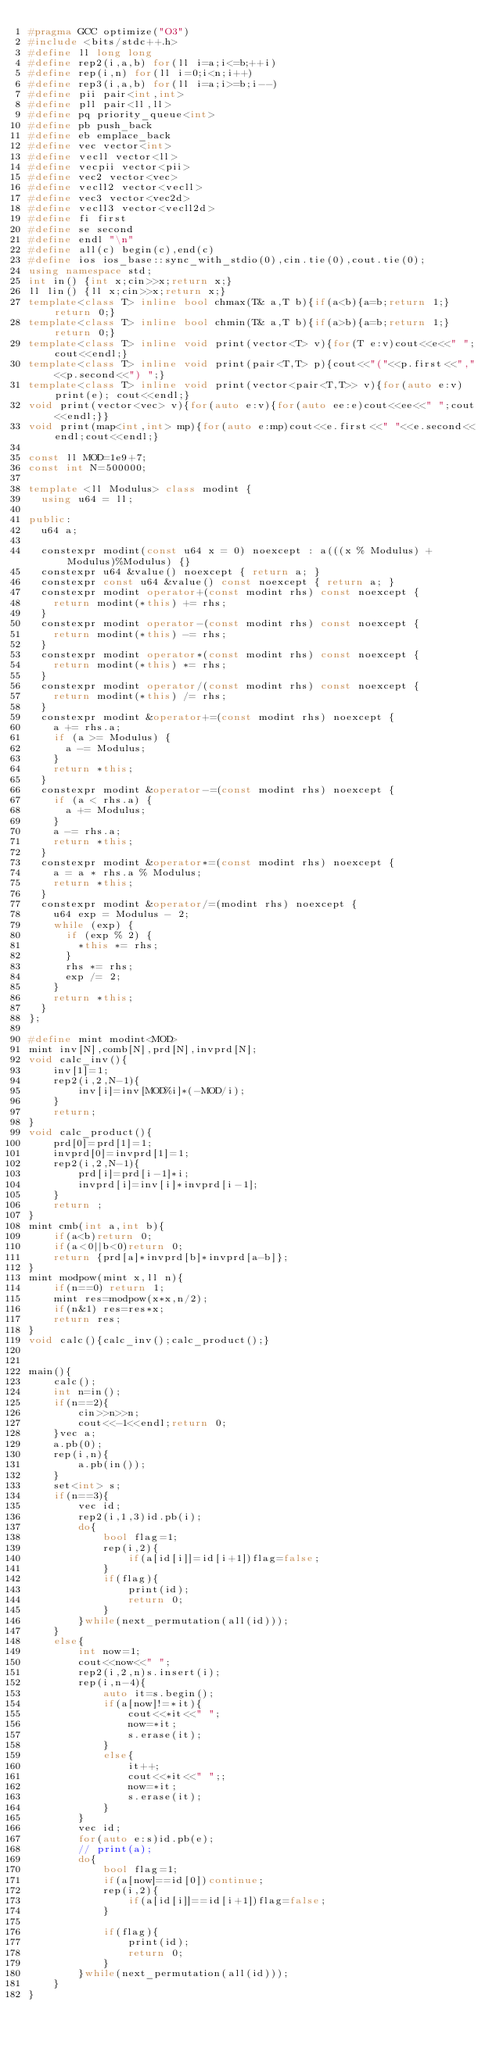Convert code to text. <code><loc_0><loc_0><loc_500><loc_500><_C++_>#pragma GCC optimize("O3")
#include <bits/stdc++.h>
#define ll long long
#define rep2(i,a,b) for(ll i=a;i<=b;++i)
#define rep(i,n) for(ll i=0;i<n;i++)
#define rep3(i,a,b) for(ll i=a;i>=b;i--)
#define pii pair<int,int>
#define pll pair<ll,ll>
#define pq priority_queue<int>
#define pb push_back
#define eb emplace_back
#define vec vector<int>
#define vecll vector<ll>
#define vecpii vector<pii>
#define vec2 vector<vec>
#define vecll2 vector<vecll>
#define vec3 vector<vec2d>
#define vecll3 vector<vecll2d>
#define fi first
#define se second
#define endl "\n"
#define all(c) begin(c),end(c)
#define ios ios_base::sync_with_stdio(0),cin.tie(0),cout.tie(0);
using namespace std;
int in() {int x;cin>>x;return x;}
ll lin() {ll x;cin>>x;return x;}
template<class T> inline bool chmax(T& a,T b){if(a<b){a=b;return 1;}return 0;}
template<class T> inline bool chmin(T& a,T b){if(a>b){a=b;return 1;}return 0;}
template<class T> inline void print(vector<T> v){for(T e:v)cout<<e<<" ";cout<<endl;}
template<class T> inline void print(pair<T,T> p){cout<<"("<<p.first<<","<<p.second<<") ";}
template<class T> inline void print(vector<pair<T,T>> v){for(auto e:v)print(e); cout<<endl;}
void print(vector<vec> v){for(auto e:v){for(auto ee:e)cout<<ee<<" ";cout<<endl;}}
void print(map<int,int> mp){for(auto e:mp)cout<<e.first<<" "<<e.second<<endl;cout<<endl;}

const ll MOD=1e9+7;
const int N=500000;
 
template <ll Modulus> class modint {
  using u64 = ll;
 
public:
  u64 a;
 
  constexpr modint(const u64 x = 0) noexcept : a(((x % Modulus) + Modulus)%Modulus) {}
  constexpr u64 &value() noexcept { return a; }
  constexpr const u64 &value() const noexcept { return a; }
  constexpr modint operator+(const modint rhs) const noexcept {
    return modint(*this) += rhs;
  }
  constexpr modint operator-(const modint rhs) const noexcept {
    return modint(*this) -= rhs;
  }
  constexpr modint operator*(const modint rhs) const noexcept {
    return modint(*this) *= rhs;
  }
  constexpr modint operator/(const modint rhs) const noexcept {
    return modint(*this) /= rhs;
  }
  constexpr modint &operator+=(const modint rhs) noexcept {
    a += rhs.a;
    if (a >= Modulus) {
      a -= Modulus;
    }
    return *this;
  }
  constexpr modint &operator-=(const modint rhs) noexcept {
    if (a < rhs.a) {
      a += Modulus;
    }
    a -= rhs.a;
    return *this;
  }
  constexpr modint &operator*=(const modint rhs) noexcept {
    a = a * rhs.a % Modulus;
    return *this;
  }
  constexpr modint &operator/=(modint rhs) noexcept {
    u64 exp = Modulus - 2;
    while (exp) {
      if (exp % 2) {
        *this *= rhs;
      }
      rhs *= rhs;
      exp /= 2;
    }
    return *this;
  }
};
 
#define mint modint<MOD>
mint inv[N],comb[N],prd[N],invprd[N];
void calc_inv(){
    inv[1]=1;
    rep2(i,2,N-1){
        inv[i]=inv[MOD%i]*(-MOD/i);
    }
    return;
}
void calc_product(){
    prd[0]=prd[1]=1;
    invprd[0]=invprd[1]=1;
    rep2(i,2,N-1){
        prd[i]=prd[i-1]*i;
        invprd[i]=inv[i]*invprd[i-1];
    }
    return ;
}
mint cmb(int a,int b){
    if(a<b)return 0;
    if(a<0||b<0)return 0;
    return {prd[a]*invprd[b]*invprd[a-b]};
}
mint modpow(mint x,ll n){
    if(n==0) return 1;
    mint res=modpow(x*x,n/2);
    if(n&1) res=res*x;
    return res;
}
void calc(){calc_inv();calc_product();}
 

main(){
    calc();
    int n=in();
    if(n==2){
        cin>>n>>n;
        cout<<-1<<endl;return 0;
    }vec a;
    a.pb(0);
    rep(i,n){
        a.pb(in());
    }
    set<int> s;
    if(n==3){
        vec id;
        rep2(i,1,3)id.pb(i);
        do{
            bool flag=1;
            rep(i,2){
                if(a[id[i]]=id[i+1])flag=false;
            }
            if(flag){
                print(id);
                return 0;
            }
        }while(next_permutation(all(id)));
    }
    else{
        int now=1;
        cout<<now<<" ";
        rep2(i,2,n)s.insert(i);
        rep(i,n-4){
            auto it=s.begin();
            if(a[now]!=*it){
                cout<<*it<<" ";
                now=*it;
                s.erase(it);
            }
            else{
                it++;
                cout<<*it<<" ";;
                now=*it;
                s.erase(it);
            }
        }
        vec id;
        for(auto e:s)id.pb(e);
        // print(a);
        do{
            bool flag=1;
            if(a[now]==id[0])continue;
            rep(i,2){
                if(a[id[i]]==id[i+1])flag=false;
            }
            
            if(flag){
                print(id);
                return 0;
            }
        }while(next_permutation(all(id)));
    }
}
</code> 